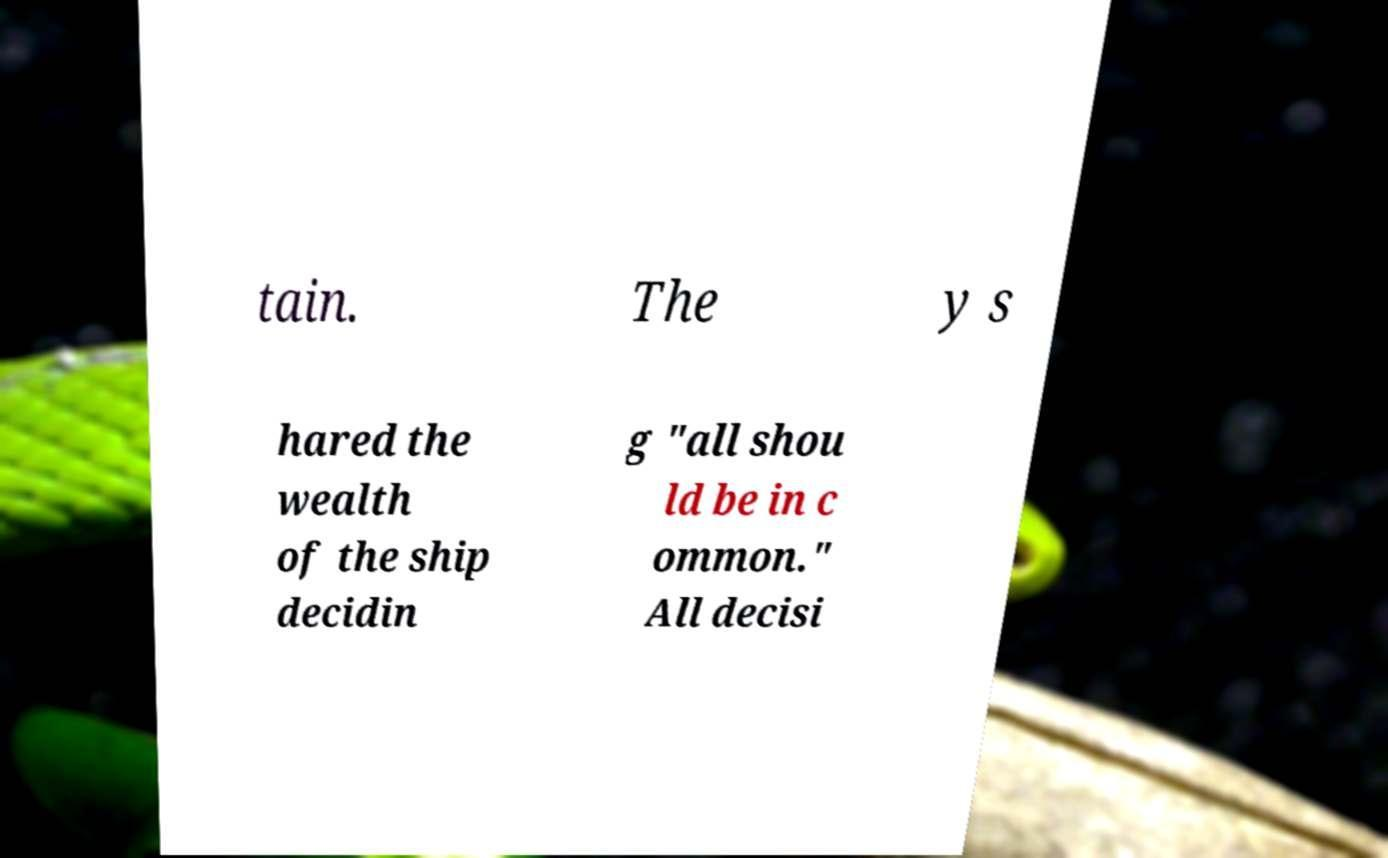For documentation purposes, I need the text within this image transcribed. Could you provide that? tain. The y s hared the wealth of the ship decidin g "all shou ld be in c ommon." All decisi 